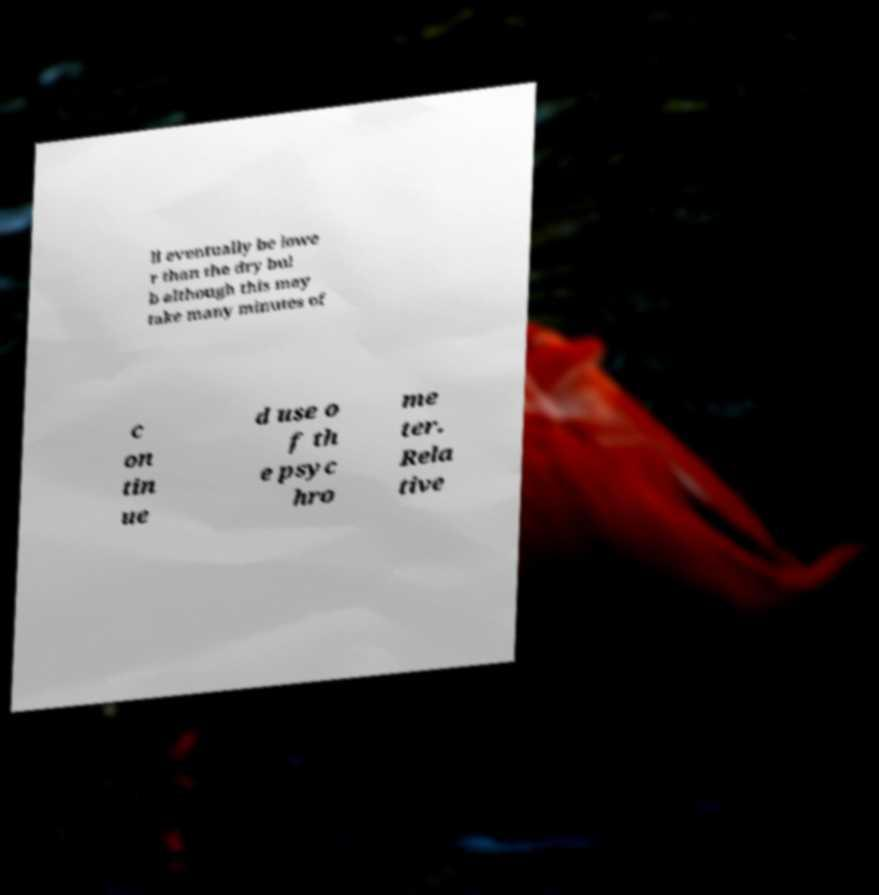Can you accurately transcribe the text from the provided image for me? ll eventually be lowe r than the dry bul b although this may take many minutes of c on tin ue d use o f th e psyc hro me ter. Rela tive 